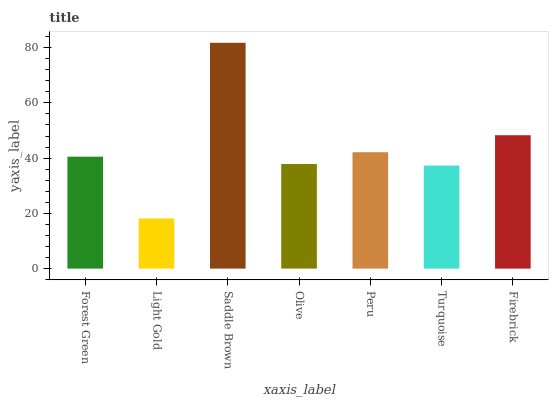Is Light Gold the minimum?
Answer yes or no. Yes. Is Saddle Brown the maximum?
Answer yes or no. Yes. Is Saddle Brown the minimum?
Answer yes or no. No. Is Light Gold the maximum?
Answer yes or no. No. Is Saddle Brown greater than Light Gold?
Answer yes or no. Yes. Is Light Gold less than Saddle Brown?
Answer yes or no. Yes. Is Light Gold greater than Saddle Brown?
Answer yes or no. No. Is Saddle Brown less than Light Gold?
Answer yes or no. No. Is Forest Green the high median?
Answer yes or no. Yes. Is Forest Green the low median?
Answer yes or no. Yes. Is Saddle Brown the high median?
Answer yes or no. No. Is Firebrick the low median?
Answer yes or no. No. 